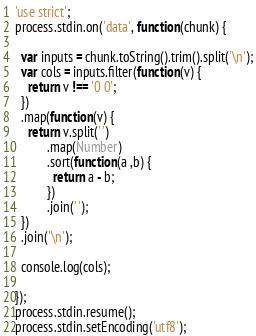Convert code to text. <code><loc_0><loc_0><loc_500><loc_500><_JavaScript_>'use strict';
process.stdin.on('data', function(chunk) {
   
  var inputs = chunk.toString().trim().split('\n');
  var cols = inputs.filter(function(v) {
    return v !== '0 0';
  })
  .map(function(v) {
    return v.split(' ')
          .map(Number)
          .sort(function(a ,b) {
            return a - b;
          })
          .join(' ');
  })
  .join('\n');
   
  console.log(cols);
   
});
process.stdin.resume();
process.stdin.setEncoding('utf8');</code> 